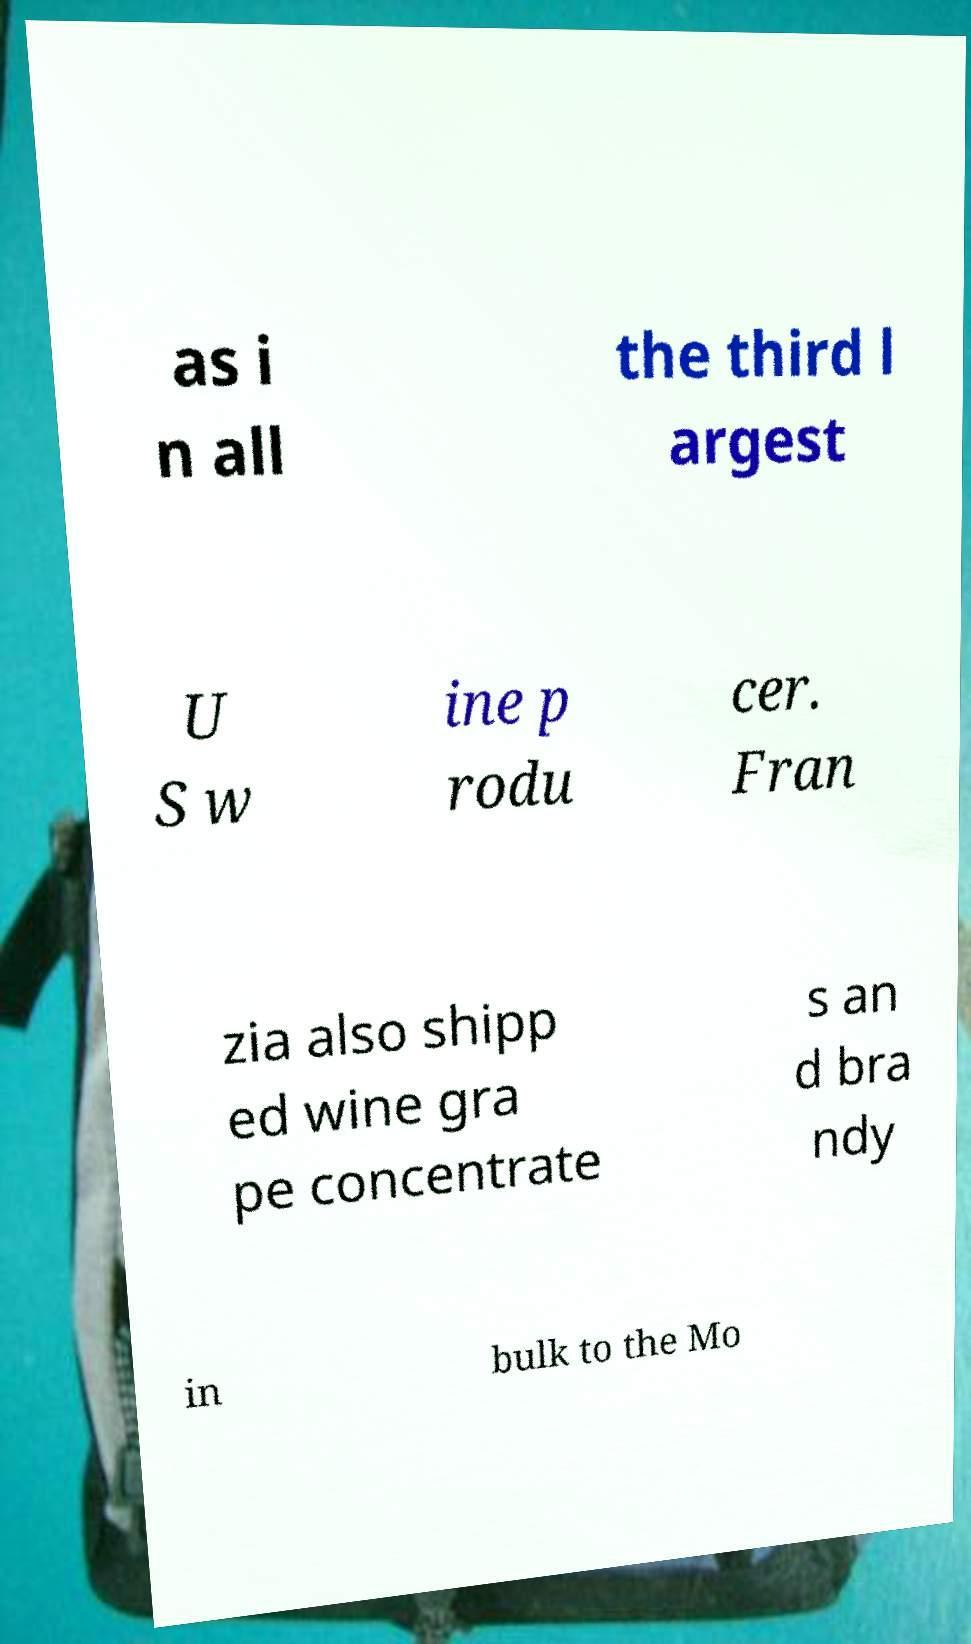What messages or text are displayed in this image? I need them in a readable, typed format. as i n all the third l argest U S w ine p rodu cer. Fran zia also shipp ed wine gra pe concentrate s an d bra ndy in bulk to the Mo 